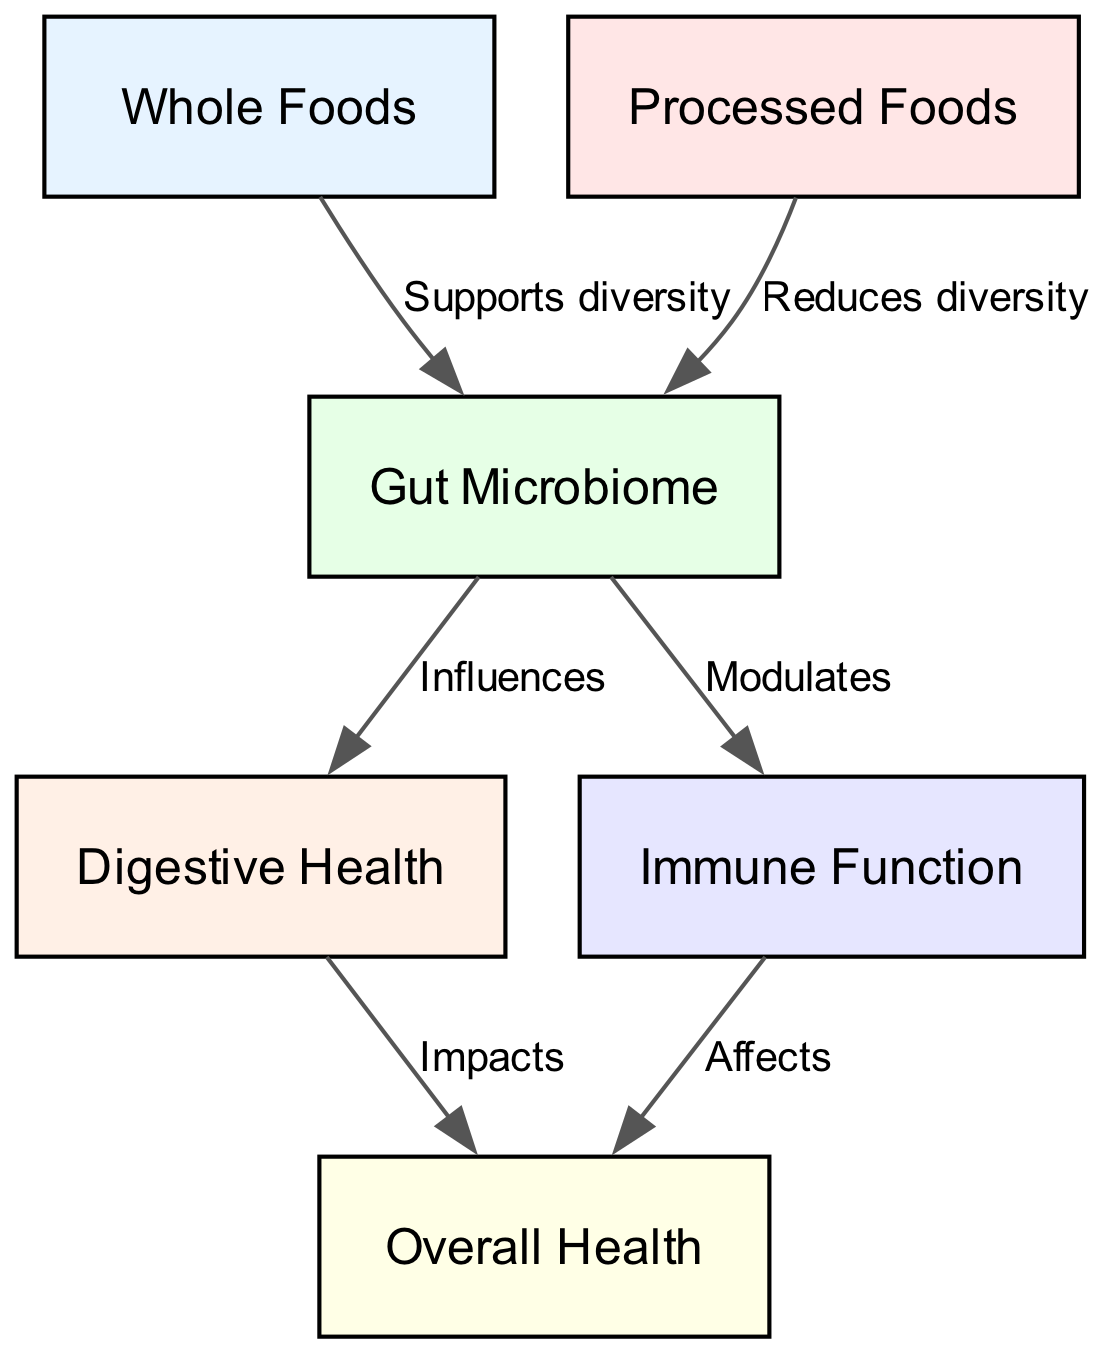What are the two main categories of food in the diagram? The diagram identifies "Whole Foods" and "Processed Foods" as the two primary food categories represented as nodes.
Answer: Whole Foods, Processed Foods How many relationships (edges) are depicted in the diagram? The diagram presents a total of six edges that illustrate the connections between the nodes, indicating the relationships.
Answer: 6 What effect do Whole Foods have on Gut Microbiome? According to the diagram, Whole Foods "Supports diversity" in the Gut Microbiome, which indicates a positive impact on its diversity.
Answer: Supports diversity What is the relationship between Gut Microbiome and Digestive Health? The diagram shows that the Gut Microbiome "Influences" Digestive Health, indicating that changes in the microbiome can affect digestive outcomes.
Answer: Influences Which type of food reduces the diversity of the Gut Microbiome? The diagram specifies that "Processed Foods" are linked to a reduction in the diversity of the Gut Microbiome, representing a negative effect.
Answer: Processed Foods How does Digestive Health impact Overall Health? The diagram states that Digestive Health "Impacts" Overall Health, suggesting that improvements in digestive function can enhance overall well-being.
Answer: Impacts What does the Gut Microbiome do for Immune Function? The diagram indicates that the Gut Microbiome "Modulates" Immune Function, meaning it plays a role in regulating immune responses.
Answer: Modulates Which node has the most outgoing relationships? The Gut Microbiome acts as a central node with two outgoing edges leading to both Digestive Health and Immune Function, thus having multiple connections.
Answer: Gut Microbiome What is the link between Processed Foods and Immune Function? Although the diagram doesn't directly specify a link between Processed Foods and Immune Function, it infers that reduced gut diversity from processed foods may indirectly affect immune function through the Gut Microbiome.
Answer: No direct link 